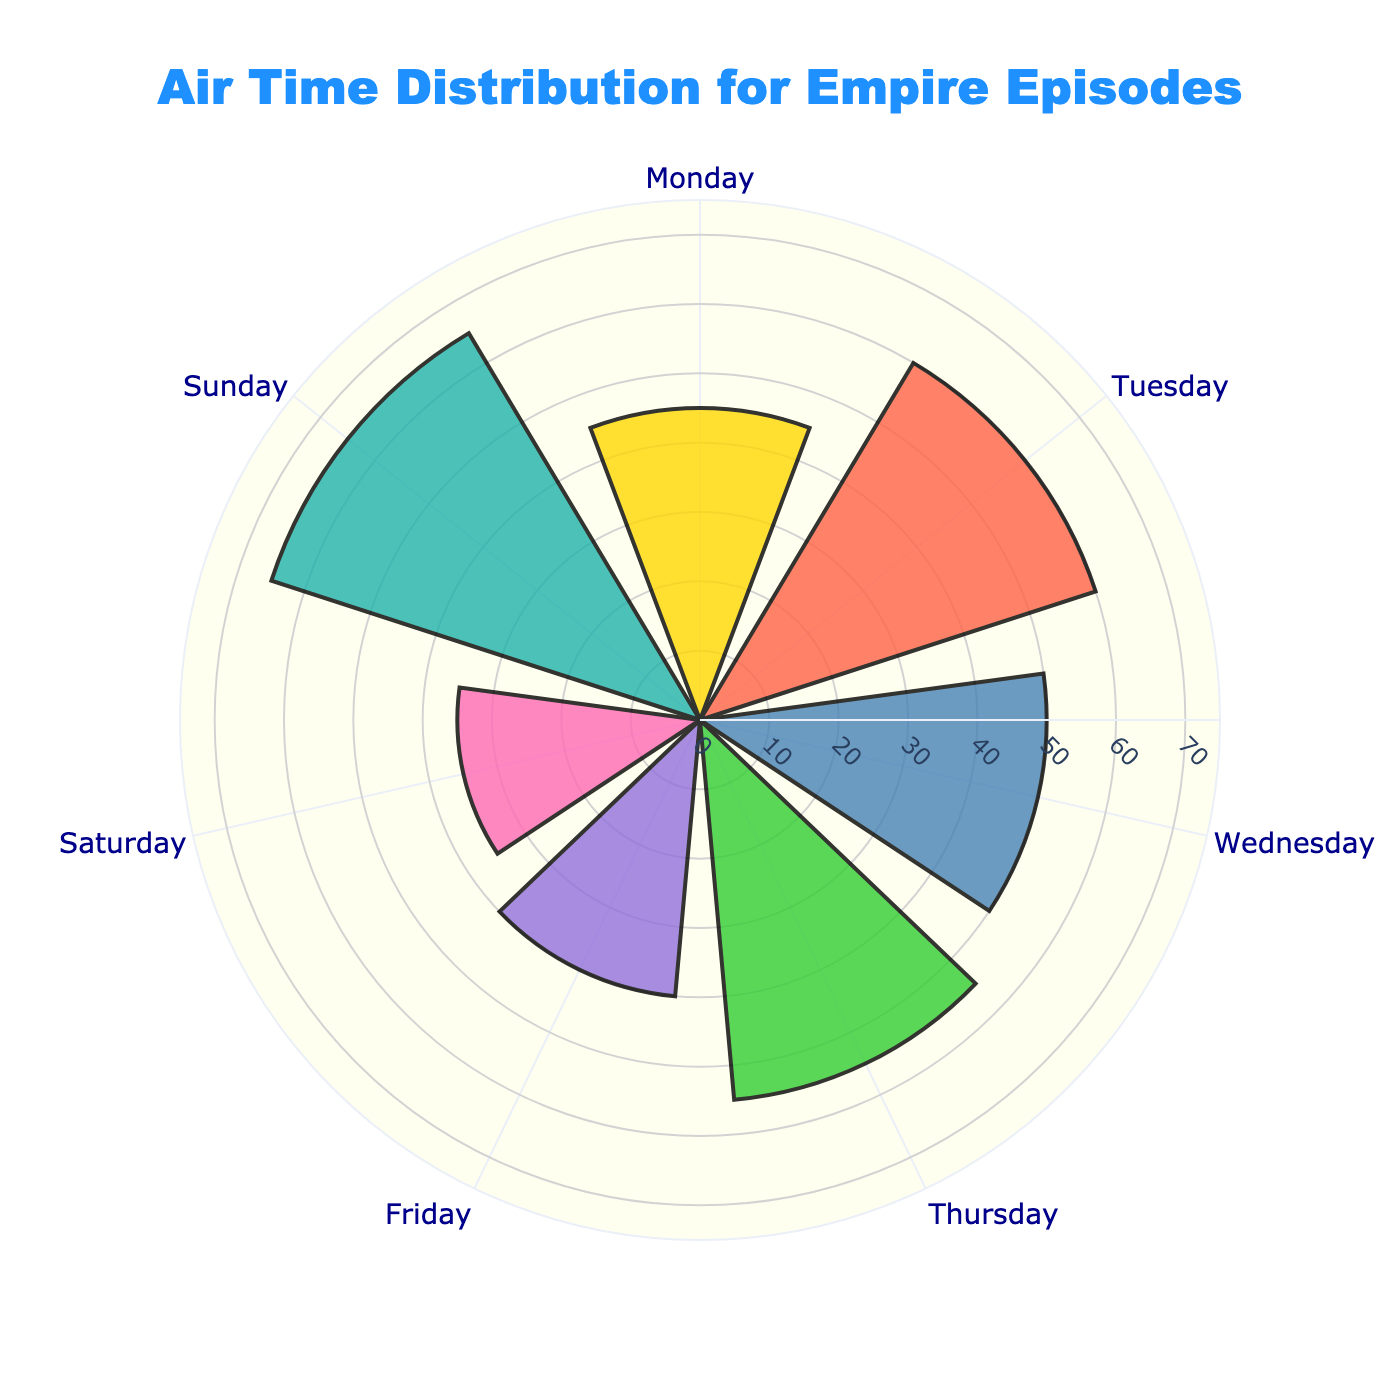What is the title of the rose chart? The title of a rose chart is typically displayed at the top center of the chart. In this case, it's indicated by the 'title' attribute in the layout.
Answer: Air Time Distribution for Empire Episodes Which day has the longest air time? To find the longest air time, look for the bar that extends the furthest from the center of the rose chart. According to the 'Air Time (minutes)' values, Sunday has the longest air time at 65 minutes.
Answer: Sunday Which day has the shortest air time? To identify the shortest air time, look for the bar closest to the center of the rose chart. According to the 'Air Time (minutes)' values, Saturday has the shortest air time at 35 minutes.
Answer: Saturday How much longer is the air time on Sunday compared to Friday? First find the air time for Sunday (65 minutes) and Friday (40 minutes). Then, subtract Friday's air time from Sunday's air time: 65 - 40 = 25 minutes.
Answer: 25 minutes What is the average air time across the week? To find the average air time, sum all the air times and divide by the number of days. (45 + 60 + 50 + 55 + 40 + 35 + 65) / 7 = 350 / 7 = 50 minutes.
Answer: 50 minutes Which two days have a combined air time of 100 minutes? Pair up the days and check the sums. Monday (45) + Tuesday (60) = 105; Tuesday (60) + Thursday (55) = 115; Monday (45) + Wednesday (50) = 95; Wednesday (50) + Friday (40) = 90; but Thursday (55) + Saturday (35) = 90; Monday (45) + Sunday (65) = 110; eventually, Tuesday (60) + Friday (40) = 100.
Answer: Tuesday and Friday How does Thursday's air time compare to Wednesday's? Compare the air times directly: Thursday has 55 minutes and Wednesday has 50 minutes, making Thursday's air time 5 minutes longer than Wednesday’s.
Answer: Thursday's air time is 5 minutes longer Is the air time on Saturday more or less than half of the air time on Sunday? First, calculate half of Sunday's air time: 65 / 2 = 32.5 minutes. Compare this to Saturday's air time of 35 minutes, which is more than 32.5.
Answer: More Which days have an air time longer than 50 minutes? Identify the days with air times exceeding 50 minutes. They are Tuesday (60), Thursday (55), and Sunday (65).
Answer: Tuesday, Thursday, and Sunday What percentage of the total weekly air time occurs on Monday? Calculate the total weekly air time: 350 minutes. Calculate Monday's percentage of the total: (45 / 350) * 100 ≈ 12.86%.
Answer: Approximately 12.86% 